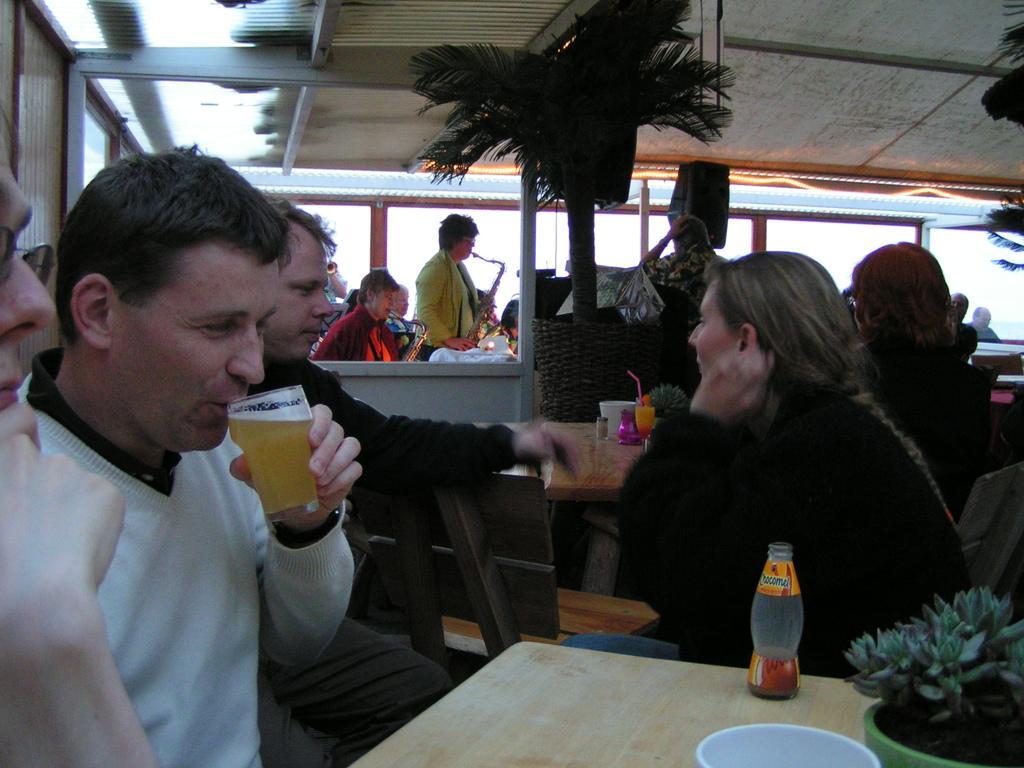Could you give a brief overview of what you see in this image? In this image I see 4 persons who are sitting on the chair and there is a table in front, On the table I see a bottle, a plant. In the background I see 2 trees, few people who are holding the musical instrument and the windows. 